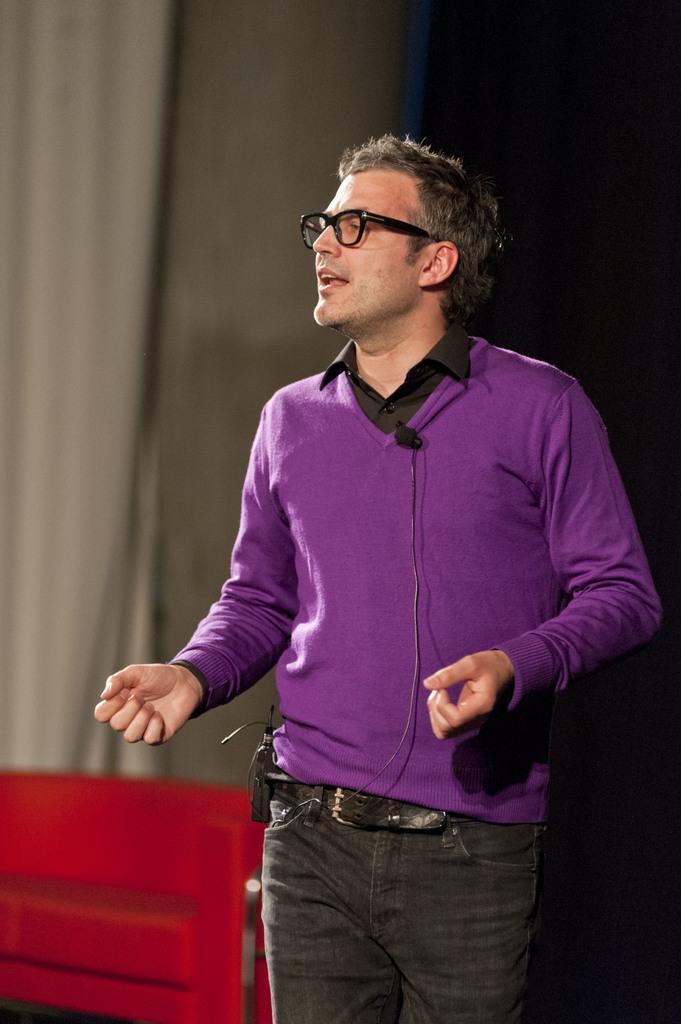Describe this image in one or two sentences. In the center of the image a man is standing and wearing spectacles. In the background of the image curtain is there. At the bottom left corner bench is there. 